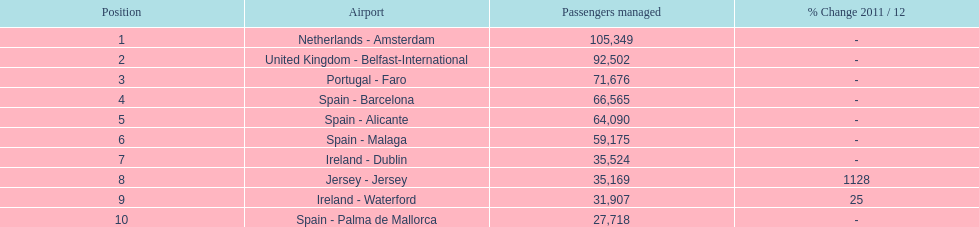Which airport has no more than 30,000 passengers handled among the 10 busiest routes to and from london southend airport in 2012? Spain - Palma de Mallorca. 